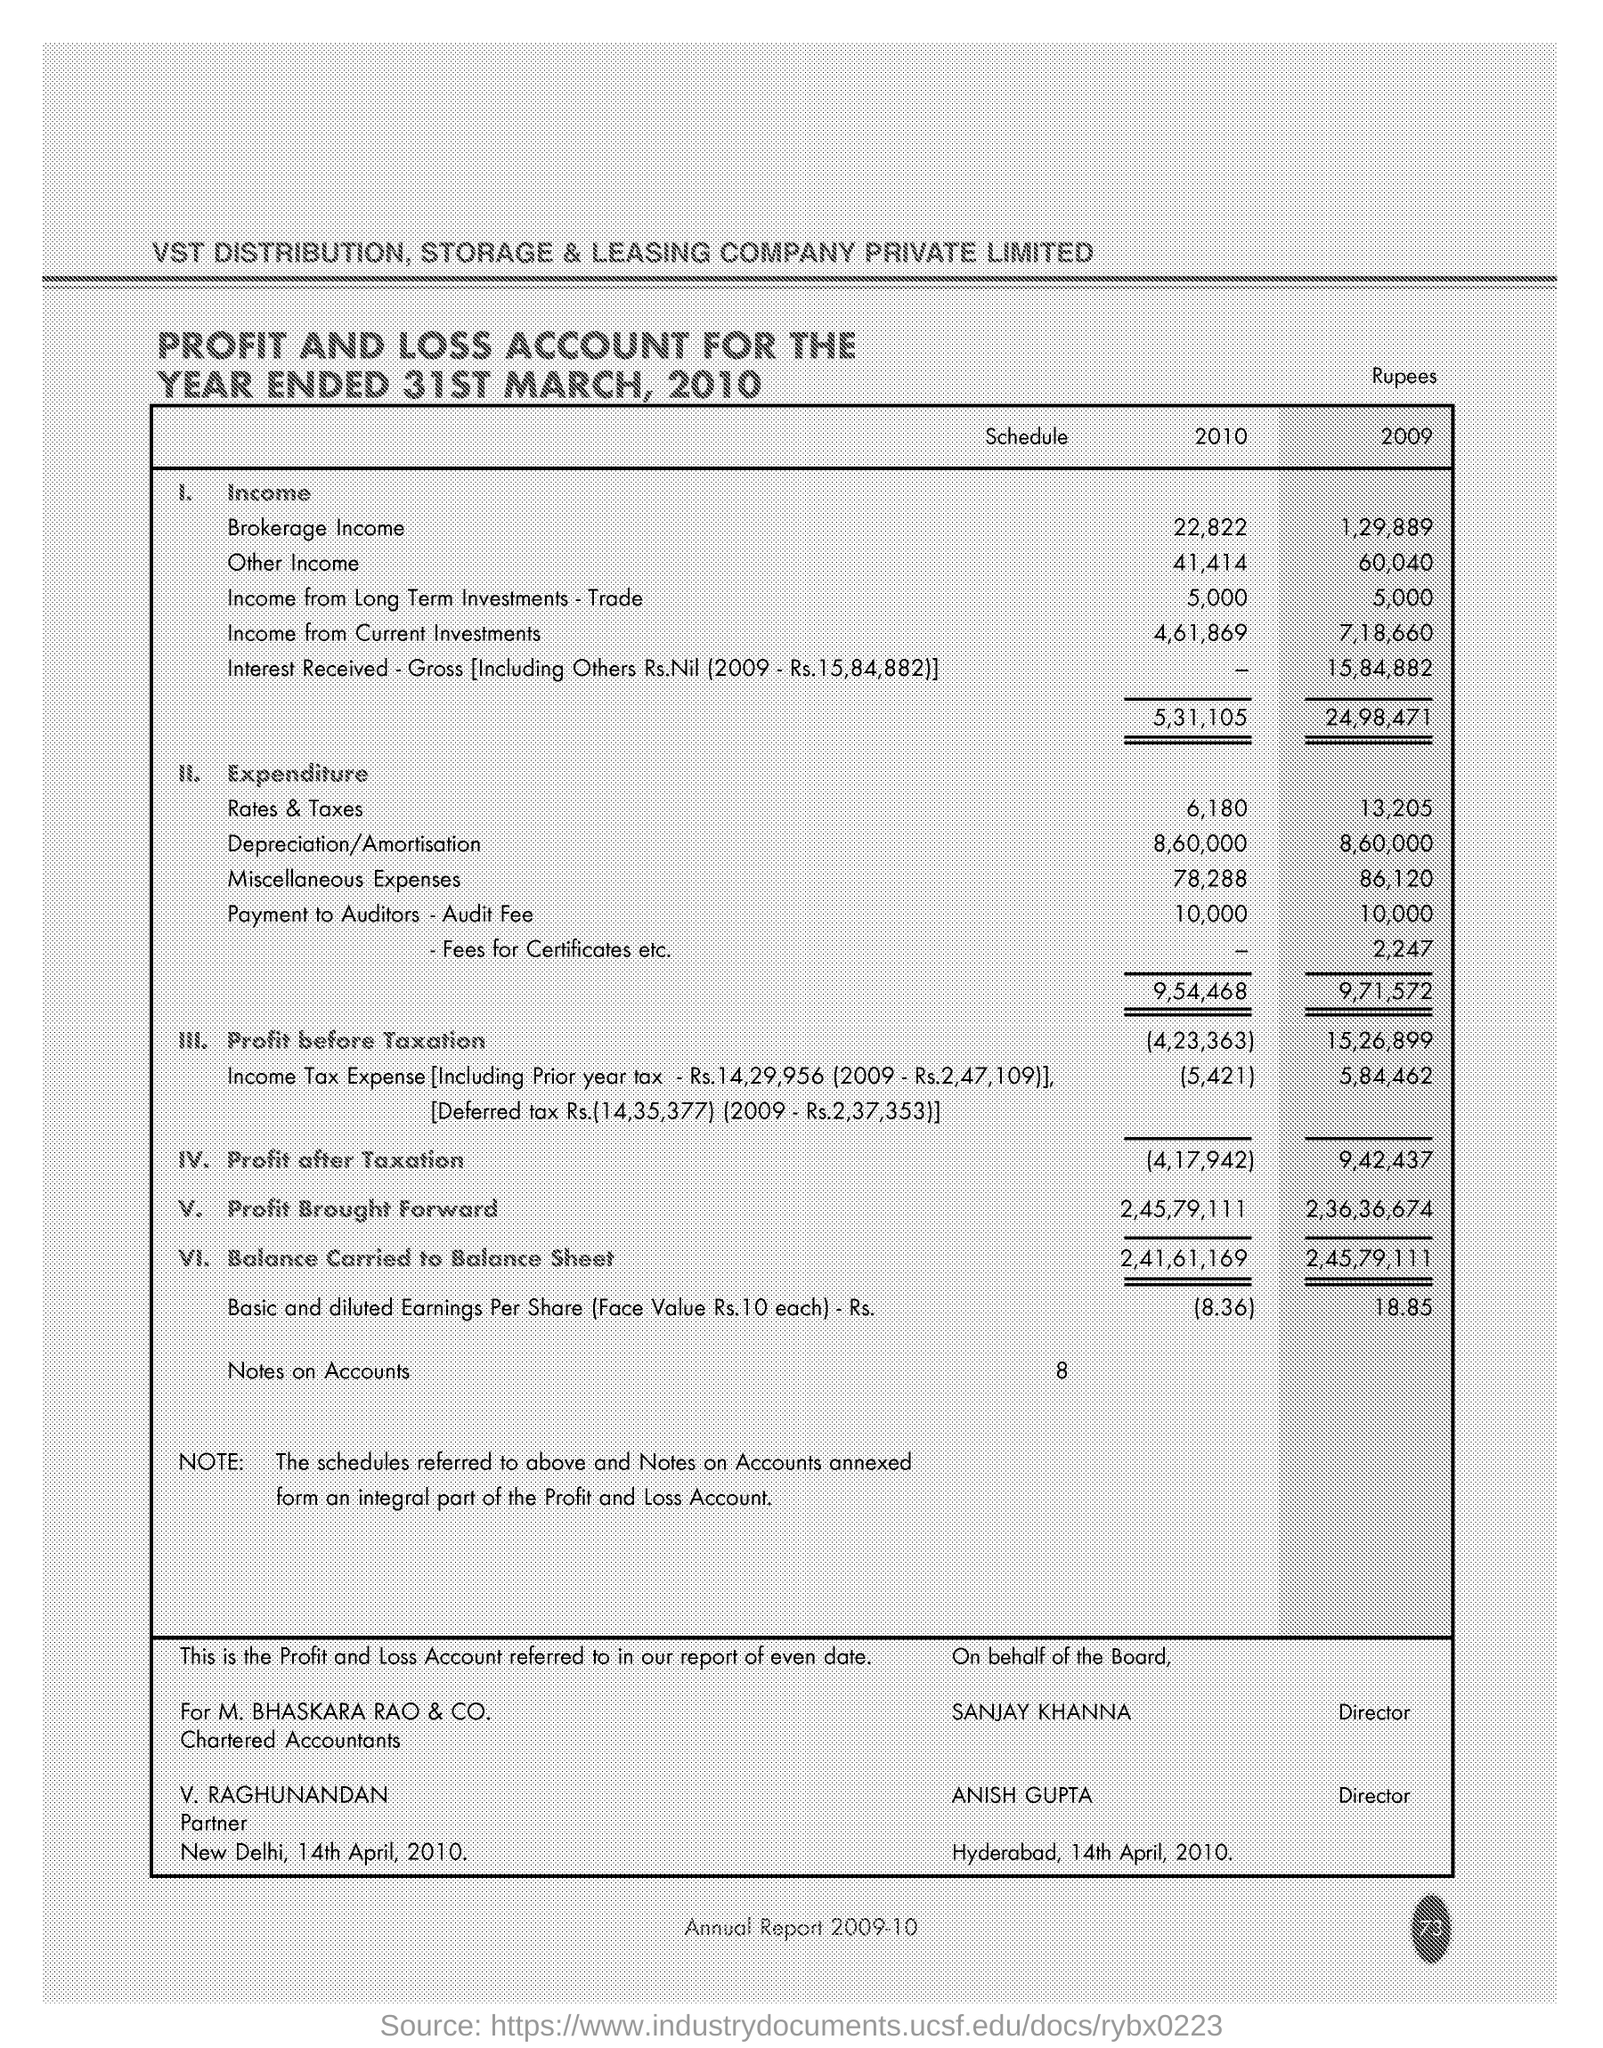Highlight a few significant elements in this photo. Based on the Profit and Loss Account for the year 2010, the brokerage income was 22,822. The year with the higher expenditure when comparing 2010 and 2009 is 2009. 